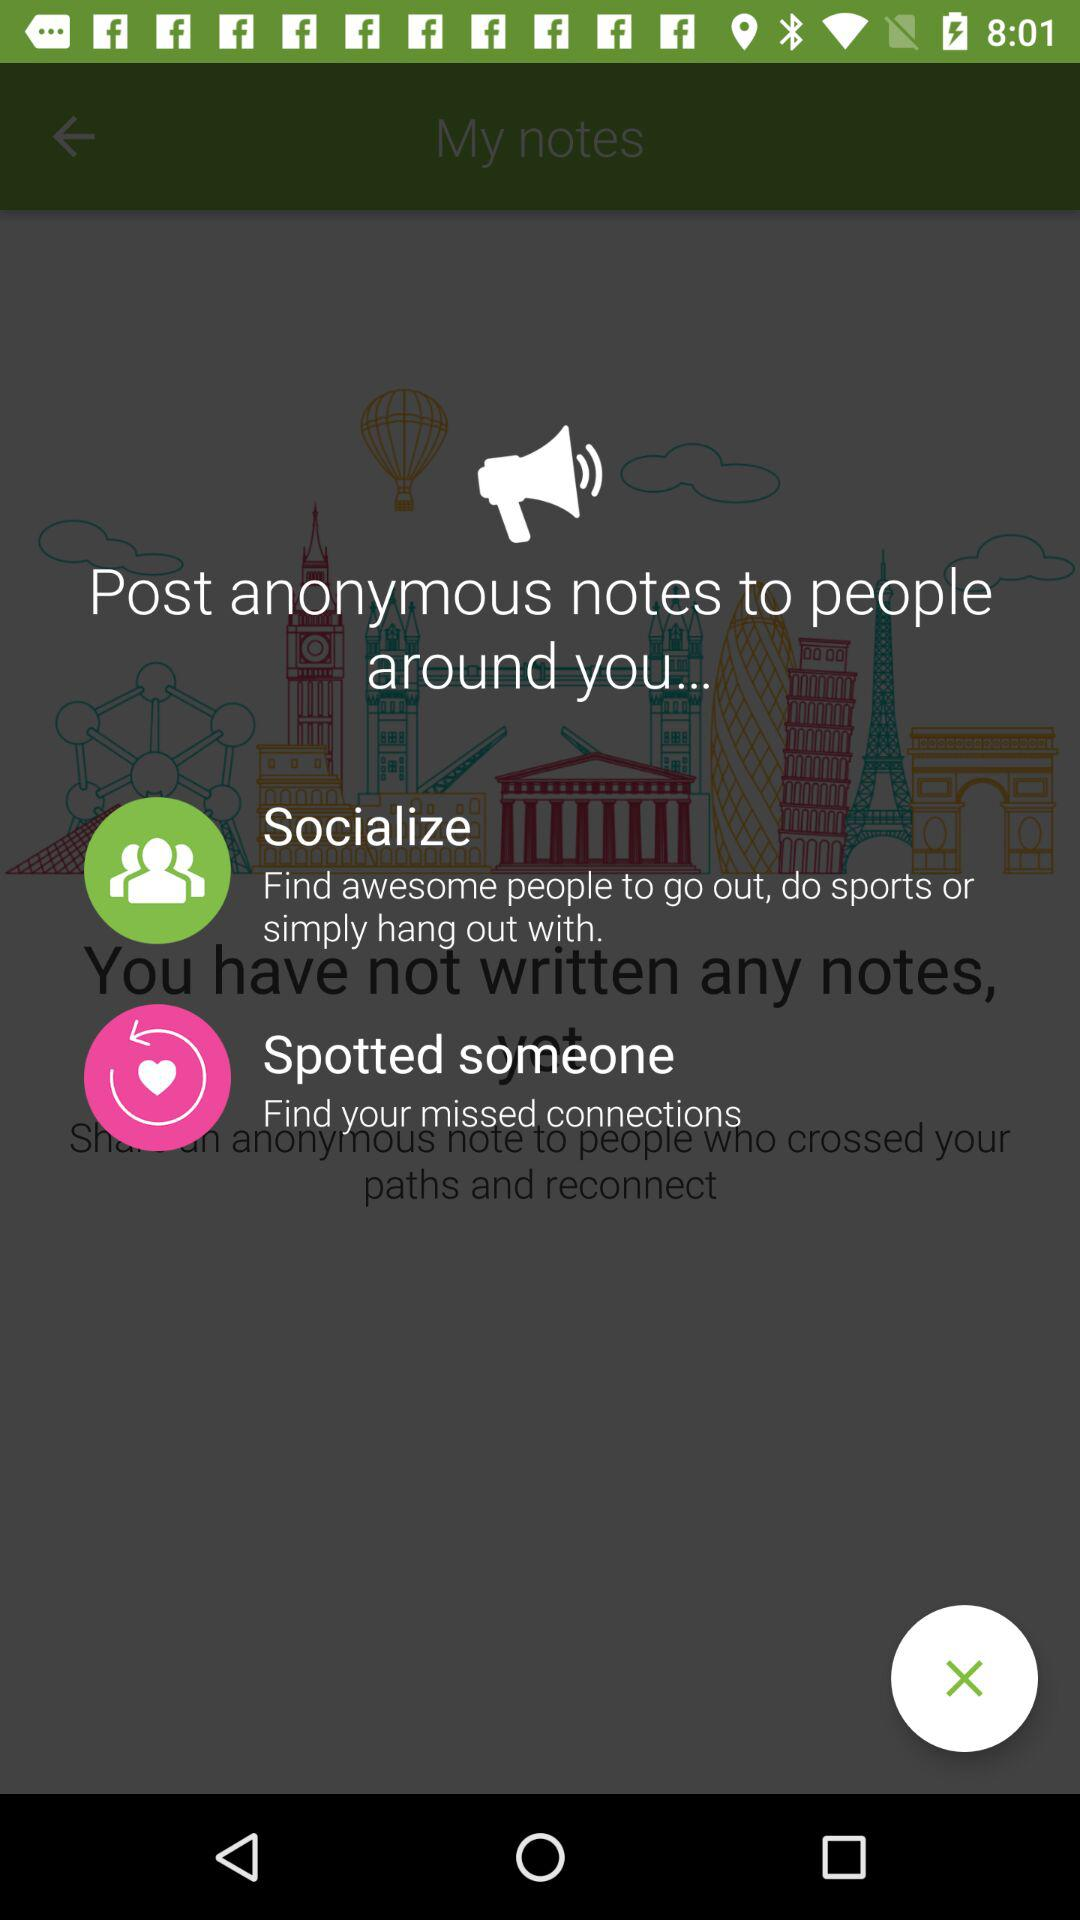What is Socialize? Socialize is about "Find awesome people to go out, do sports or simply hang out with". 